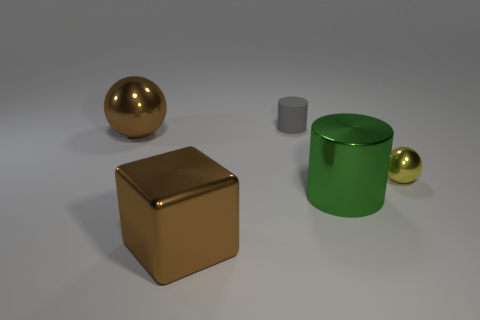Is there any other thing that has the same material as the small cylinder?
Provide a succinct answer. No. There is a brown metal thing left of the brown cube; does it have the same size as the brown metallic thing that is in front of the metal cylinder?
Keep it short and to the point. Yes. Is the number of small rubber cylinders right of the tiny gray thing greater than the number of big metal spheres that are on the left side of the big ball?
Your answer should be very brief. No. How many other things are there of the same color as the large block?
Keep it short and to the point. 1. There is a rubber object; is it the same color as the big shiny object in front of the green metal thing?
Your answer should be very brief. No. There is a small thing in front of the gray cylinder; how many big brown metal things are behind it?
Keep it short and to the point. 1. What is the material of the brown thing that is in front of the metal object on the right side of the big metal object that is to the right of the gray cylinder?
Make the answer very short. Metal. What is the material of the object that is both behind the metal cylinder and in front of the big brown metallic sphere?
Make the answer very short. Metal. How many large metallic things are the same shape as the tiny gray thing?
Your response must be concise. 1. What is the size of the ball on the right side of the metal ball on the left side of the tiny gray cylinder?
Offer a very short reply. Small. 